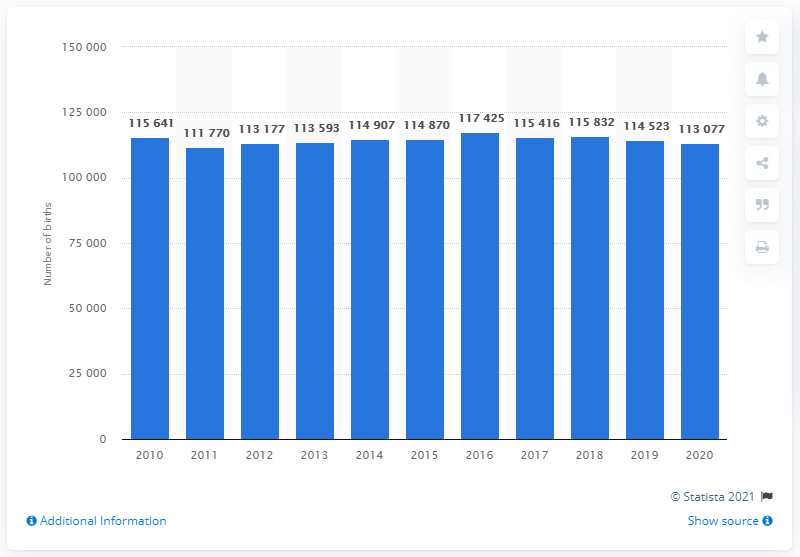List a handful of essential elements in this visual. The highest number of babies was born in Sweden in 2016. In 2020, the number of babies born in Sweden was 113,077. 